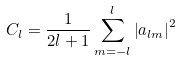<formula> <loc_0><loc_0><loc_500><loc_500>C _ { l } = \frac { 1 } { 2 l + 1 } \sum _ { m = - l } ^ { l } \left | a _ { l m } \right | ^ { 2 }</formula> 